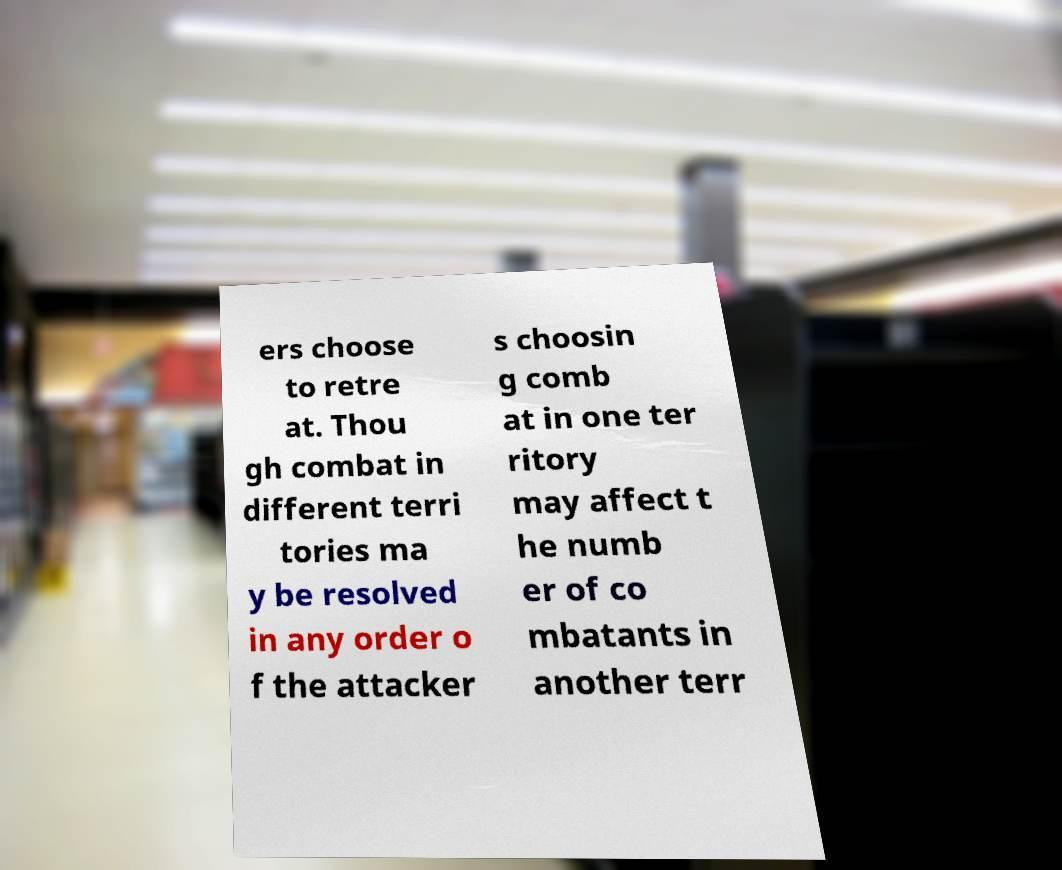Can you accurately transcribe the text from the provided image for me? ers choose to retre at. Thou gh combat in different terri tories ma y be resolved in any order o f the attacker s choosin g comb at in one ter ritory may affect t he numb er of co mbatants in another terr 